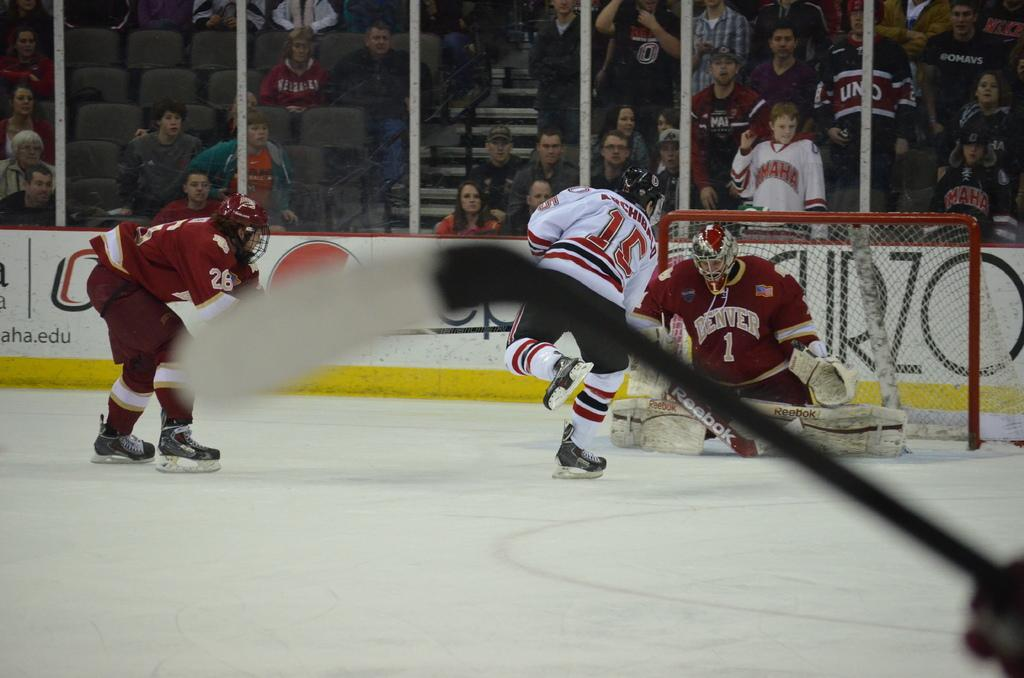<image>
Provide a brief description of the given image. A hockey game is in progress and Denver is defending the goal. 